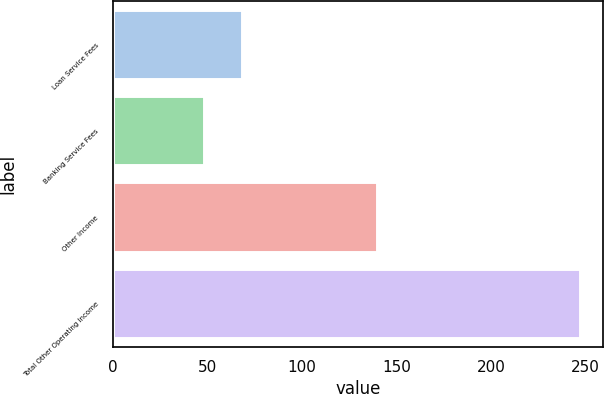Convert chart to OTSL. <chart><loc_0><loc_0><loc_500><loc_500><bar_chart><fcel>Loan Service Fees<fcel>Banking Service Fees<fcel>Other Income<fcel>Total Other Operating Income<nl><fcel>68.09<fcel>48.2<fcel>139.8<fcel>247.1<nl></chart> 